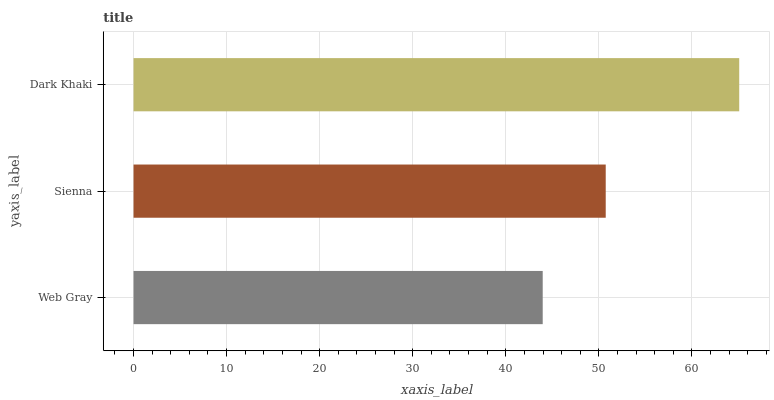Is Web Gray the minimum?
Answer yes or no. Yes. Is Dark Khaki the maximum?
Answer yes or no. Yes. Is Sienna the minimum?
Answer yes or no. No. Is Sienna the maximum?
Answer yes or no. No. Is Sienna greater than Web Gray?
Answer yes or no. Yes. Is Web Gray less than Sienna?
Answer yes or no. Yes. Is Web Gray greater than Sienna?
Answer yes or no. No. Is Sienna less than Web Gray?
Answer yes or no. No. Is Sienna the high median?
Answer yes or no. Yes. Is Sienna the low median?
Answer yes or no. Yes. Is Dark Khaki the high median?
Answer yes or no. No. Is Dark Khaki the low median?
Answer yes or no. No. 